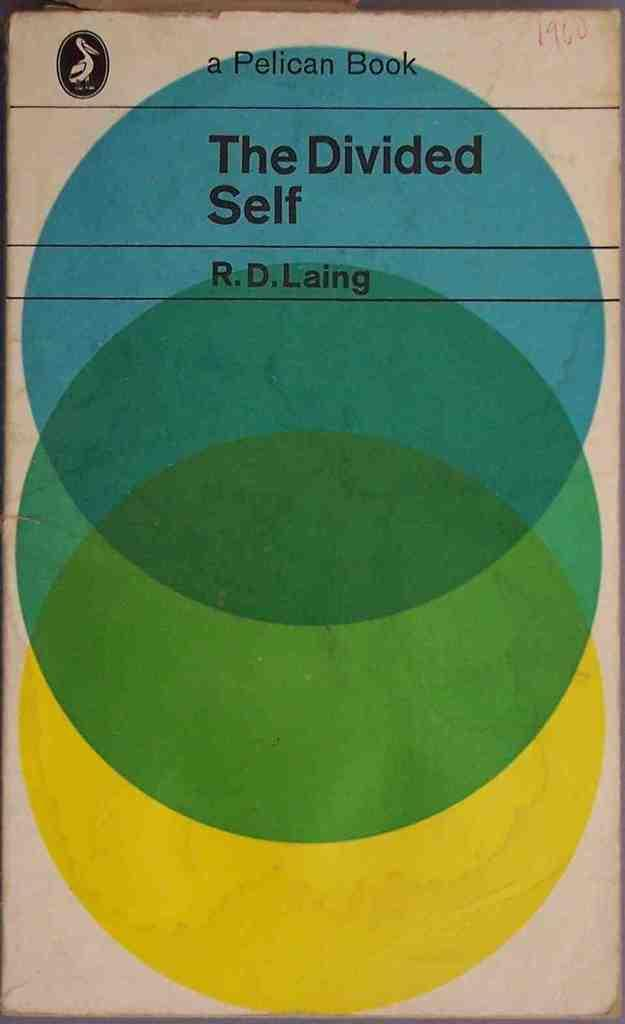<image>
Relay a brief, clear account of the picture shown. The Divided Self Pelican Book cover with three circles. 